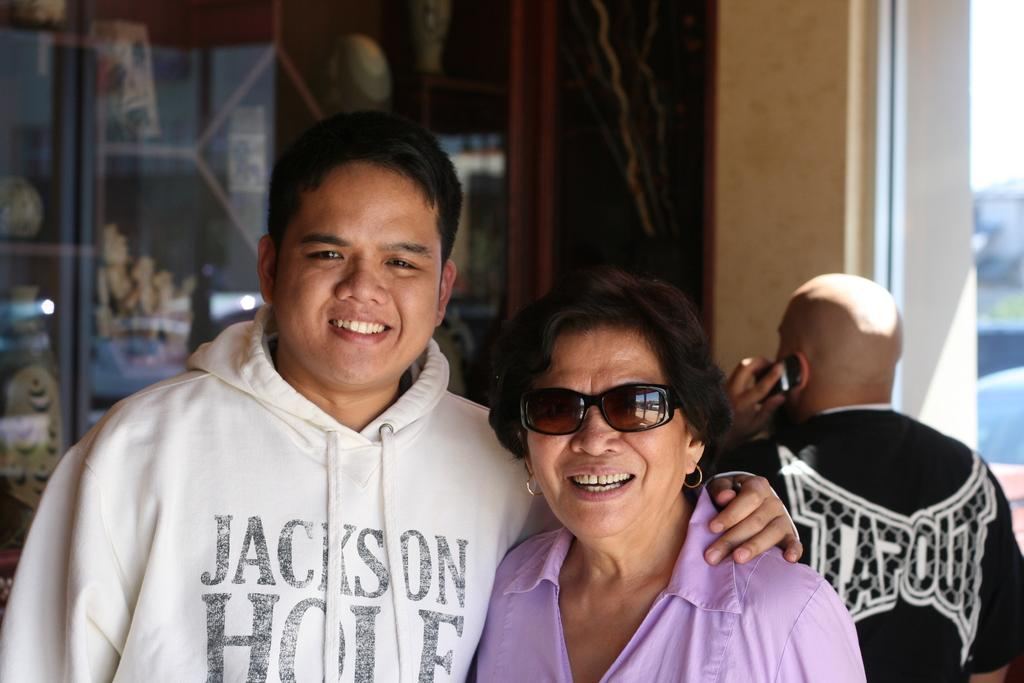How many people are present in the image? There are two people, a man and a woman, present in the image. What is the facial expression of the people in the image? Both the man and the woman are smiling in the image. Who is holding a mobile in the image? There is a person holding a mobile in the image. What can be seen in the background of the image? There is a glass, a wall, and other objects visible in the background of the image. What type of knot is being tied by the women in the image? There are no women present in the image, and no one is tying a knot. What is the celery used for in the image? There is no celery present in the image. 